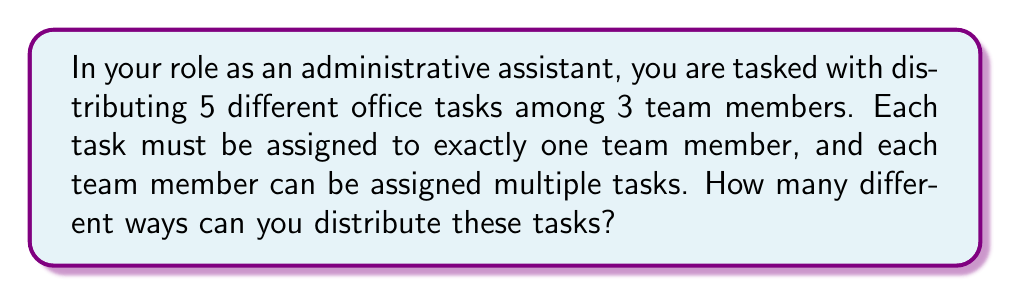What is the answer to this math problem? Let's approach this step-by-step:

1) First, we need to recognize that this is a problem of distributing distinct objects (tasks) into distinct boxes (team members).

2) For each task, we have 3 choices (team members) to assign it to.

3) Since there are 5 tasks, and each task can be independently assigned to any of the 3 team members, we can use the multiplication principle.

4) The multiplication principle states that if we have a sequence of $n$ independent choices, where the $i$-th choice has $k_i$ options, then the total number of possible outcomes is the product $k_1 \times k_2 \times ... \times k_n$.

5) In this case, we have 5 independent choices (one for each task), and each choice has 3 options (team members).

6) Therefore, the total number of ways to distribute the tasks is:

   $$3 \times 3 \times 3 \times 3 \times 3 = 3^5$$

7) Calculating this:
   
   $$3^5 = 243$$

Thus, there are 243 different ways to distribute the 5 tasks among the 3 team members.
Answer: 243 